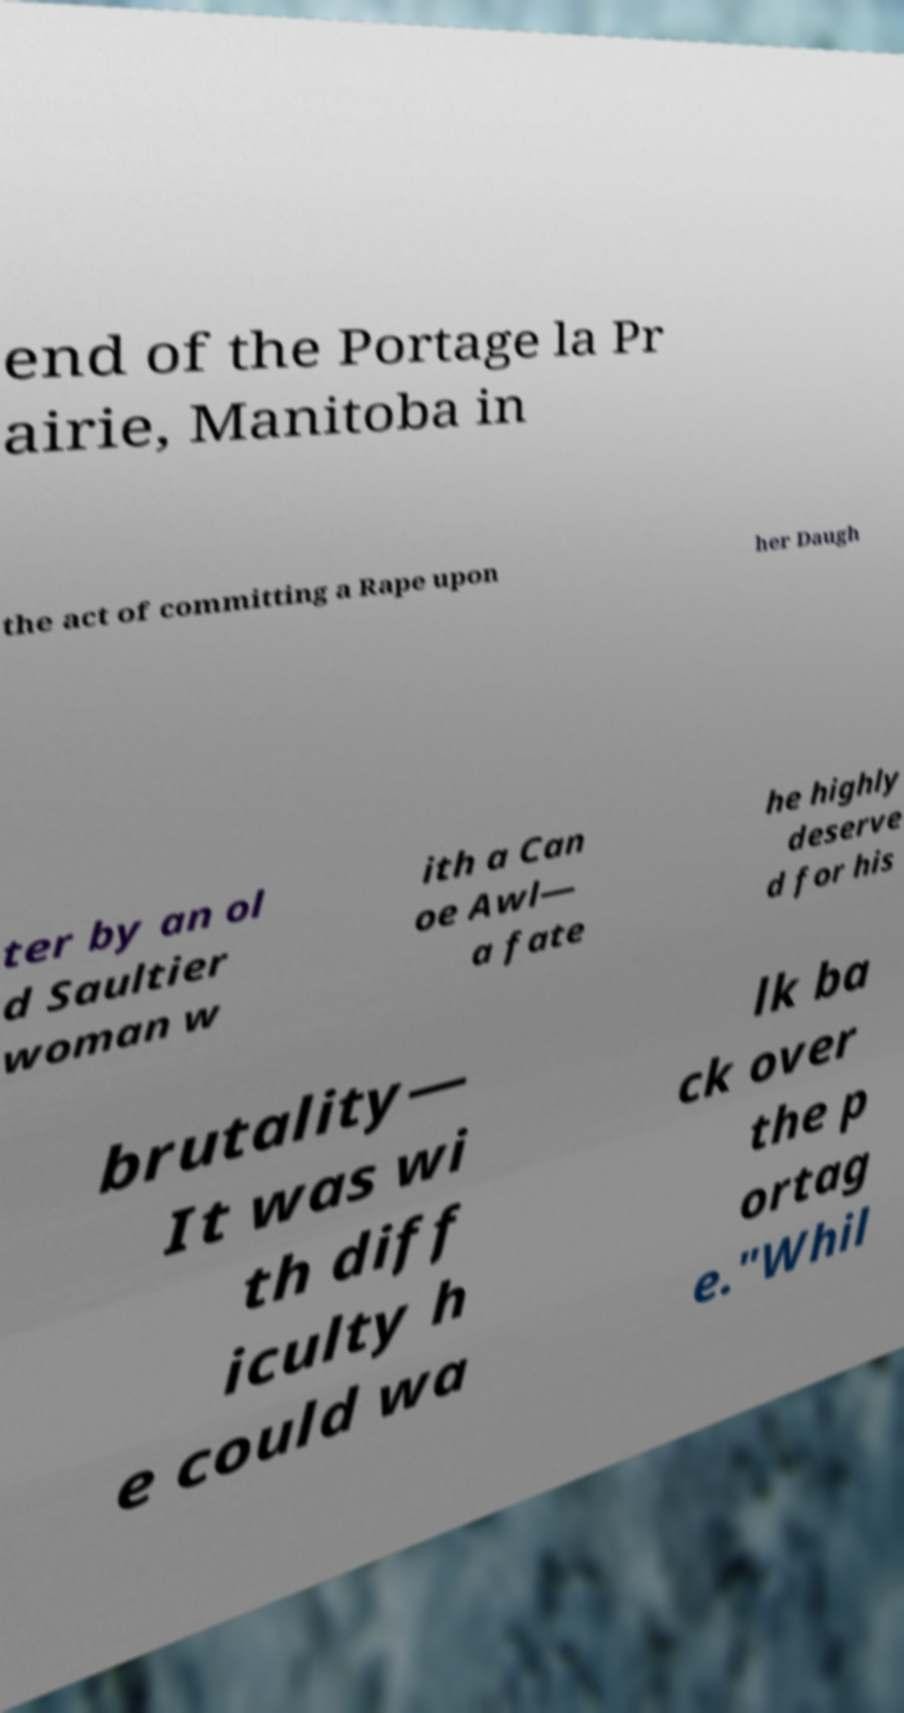There's text embedded in this image that I need extracted. Can you transcribe it verbatim? end of the Portage la Pr airie, Manitoba in the act of committing a Rape upon her Daugh ter by an ol d Saultier woman w ith a Can oe Awl— a fate he highly deserve d for his brutality— It was wi th diff iculty h e could wa lk ba ck over the p ortag e."Whil 